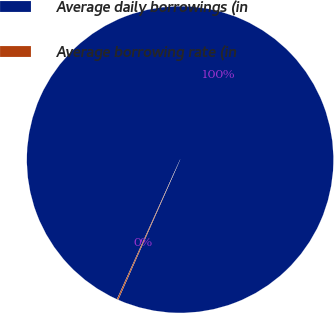Convert chart to OTSL. <chart><loc_0><loc_0><loc_500><loc_500><pie_chart><fcel>Average daily borrowings (in<fcel>Average borrowing rate (in<nl><fcel>99.87%<fcel>0.13%<nl></chart> 